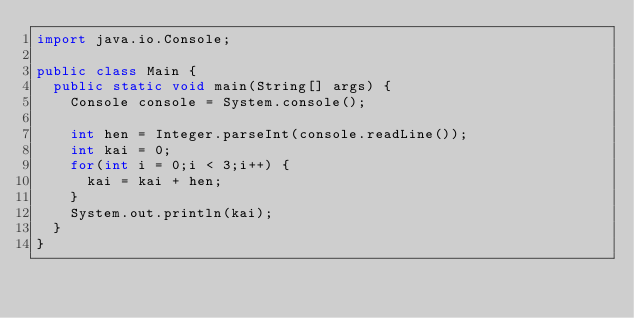<code> <loc_0><loc_0><loc_500><loc_500><_Java_>import java.io.Console;

public class Main {
	public static void main(String[] args) {
		Console console = System.console();

		int hen = Integer.parseInt(console.readLine());
		int kai = 0;
		for(int i = 0;i < 3;i++) {
			kai = kai + hen;
		}
		System.out.println(kai);
	}
}</code> 